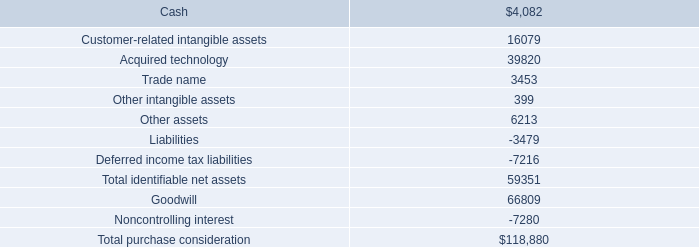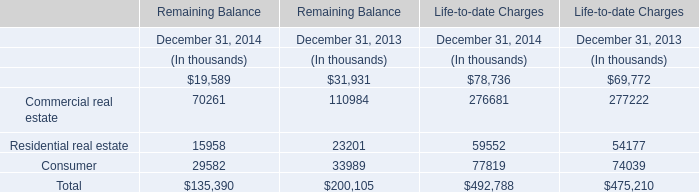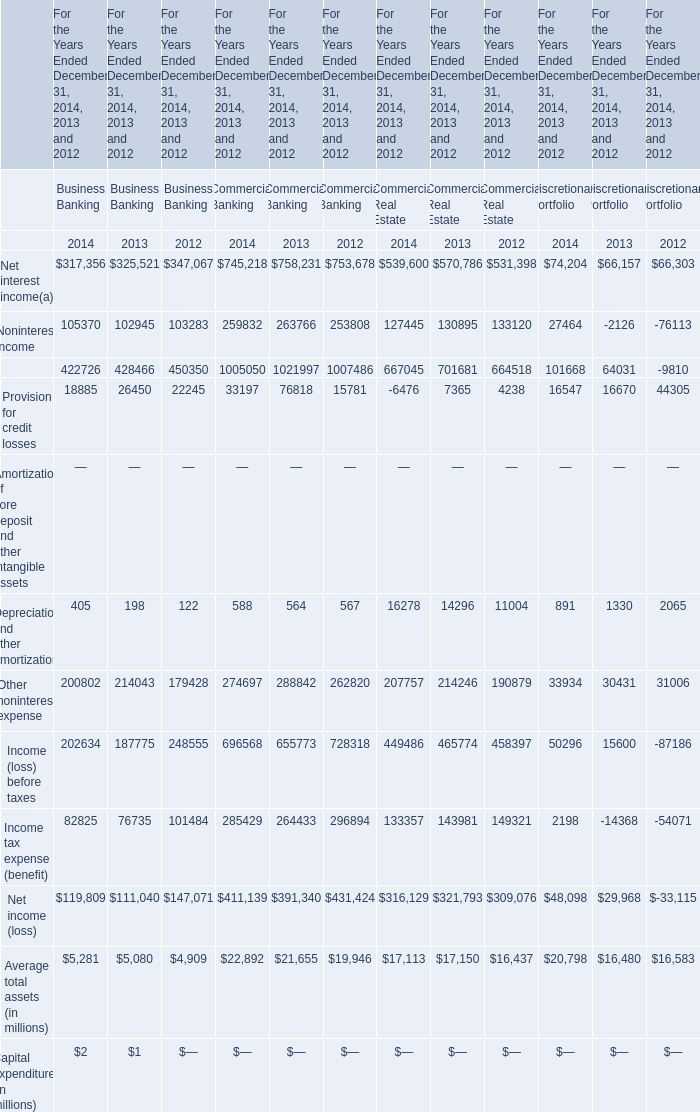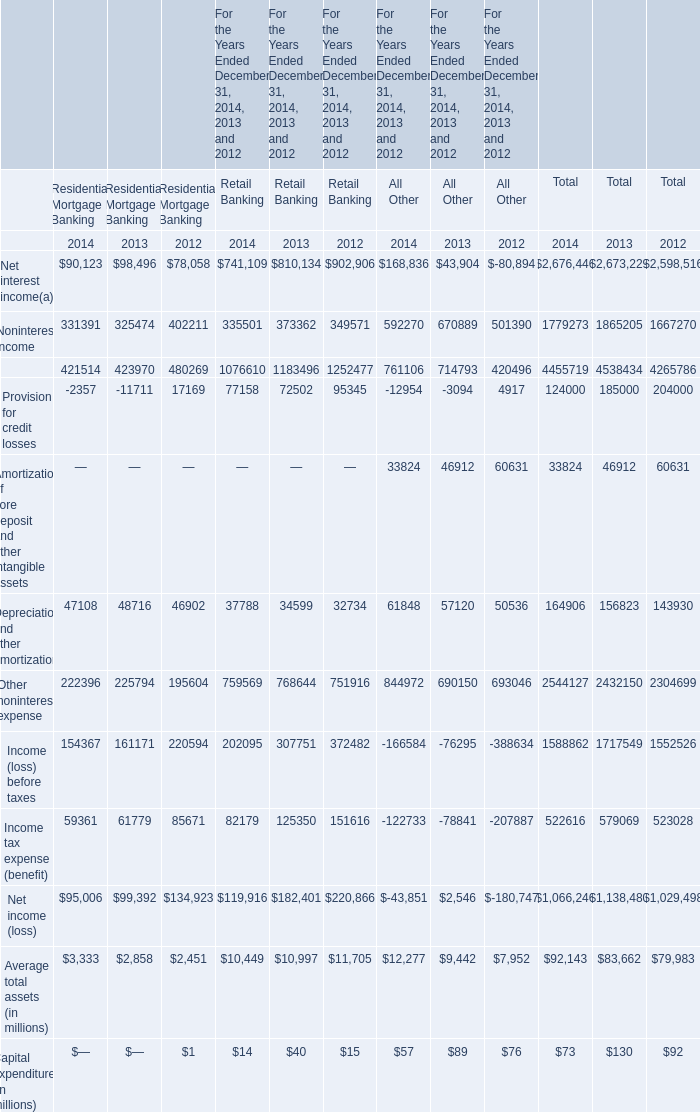In which section is Noninterest income for Commercial Banking smaller than 255000? 
Answer: 2012. 